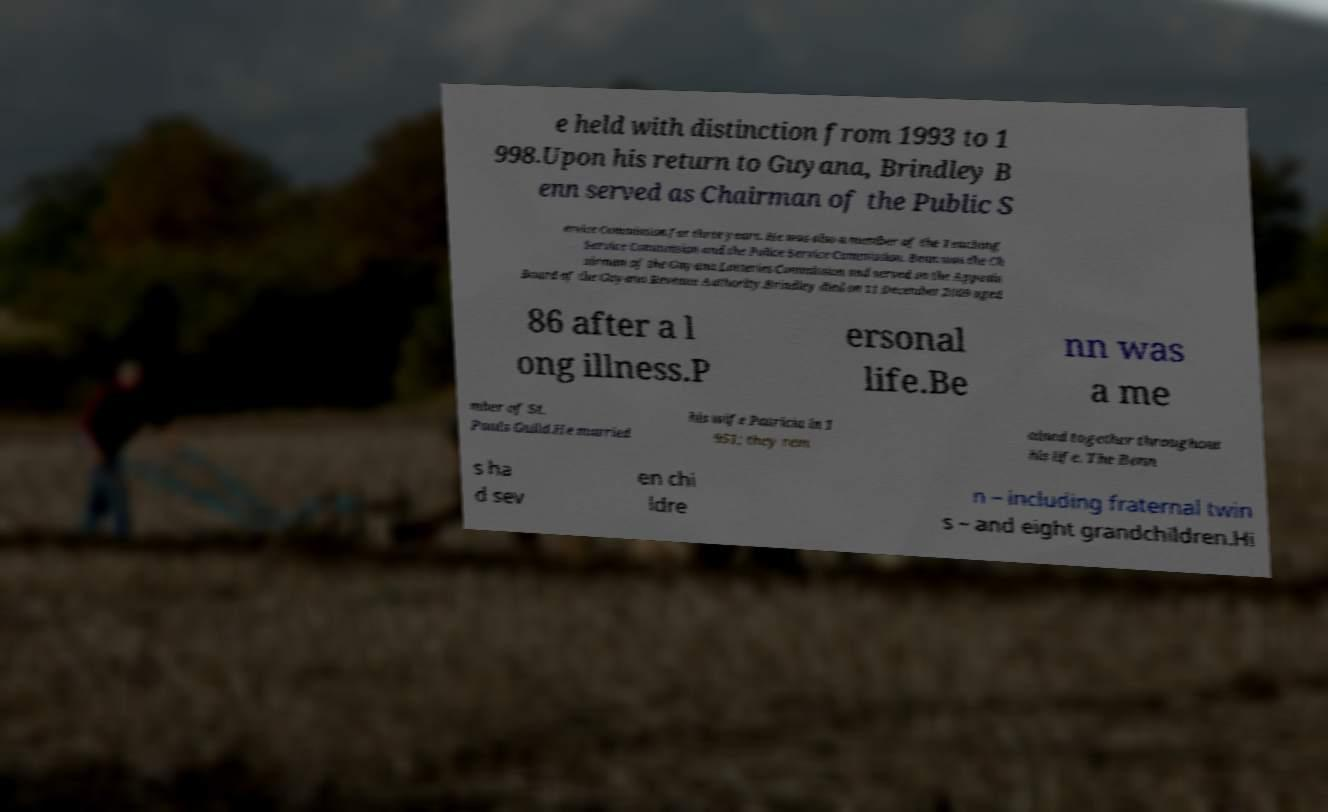For documentation purposes, I need the text within this image transcribed. Could you provide that? e held with distinction from 1993 to 1 998.Upon his return to Guyana, Brindley B enn served as Chairman of the Public S ervice Commission for three years. He was also a member of the Teaching Service Commission and the Police Service Commission. Benn was the Ch airman of the Guyana Lotteries Commission and served on the Appeals Board of the Guyana Revenue Authority.Brindley died on 11 December 2009 aged 86 after a l ong illness.P ersonal life.Be nn was a me mber of St. Pauls Guild.He married his wife Patricia in 1 951; they rem ained together throughout his life. The Benn s ha d sev en chi ldre n – including fraternal twin s – and eight grandchildren.Hi 